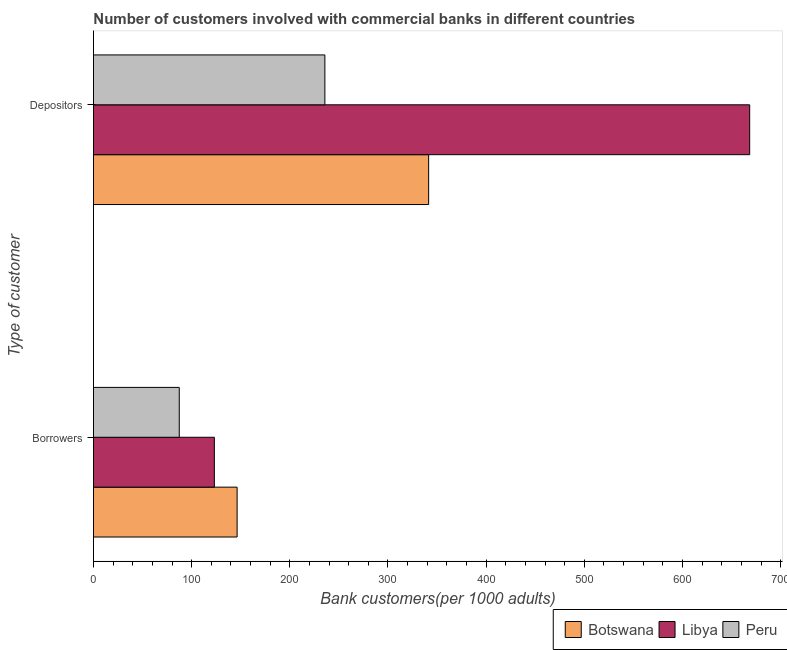How many groups of bars are there?
Your response must be concise. 2. Are the number of bars per tick equal to the number of legend labels?
Provide a succinct answer. Yes. Are the number of bars on each tick of the Y-axis equal?
Your response must be concise. Yes. How many bars are there on the 2nd tick from the top?
Keep it short and to the point. 3. What is the label of the 2nd group of bars from the top?
Your response must be concise. Borrowers. What is the number of borrowers in Peru?
Your answer should be compact. 87.41. Across all countries, what is the maximum number of borrowers?
Offer a very short reply. 146.32. Across all countries, what is the minimum number of borrowers?
Offer a terse response. 87.41. In which country was the number of borrowers maximum?
Your answer should be very brief. Botswana. In which country was the number of depositors minimum?
Offer a terse response. Peru. What is the total number of borrowers in the graph?
Your response must be concise. 356.88. What is the difference between the number of borrowers in Peru and that in Botswana?
Provide a succinct answer. -58.91. What is the difference between the number of depositors in Peru and the number of borrowers in Libya?
Keep it short and to the point. 112.56. What is the average number of depositors per country?
Offer a terse response. 415.17. What is the difference between the number of depositors and number of borrowers in Botswana?
Your answer should be compact. 195.08. What is the ratio of the number of depositors in Peru to that in Libya?
Provide a short and direct response. 0.35. In how many countries, is the number of borrowers greater than the average number of borrowers taken over all countries?
Make the answer very short. 2. What does the 1st bar from the top in Borrowers represents?
Offer a terse response. Peru. What does the 2nd bar from the bottom in Borrowers represents?
Your answer should be compact. Libya. How many bars are there?
Offer a very short reply. 6. Are all the bars in the graph horizontal?
Provide a succinct answer. Yes. How many countries are there in the graph?
Keep it short and to the point. 3. What is the difference between two consecutive major ticks on the X-axis?
Offer a very short reply. 100. Are the values on the major ticks of X-axis written in scientific E-notation?
Provide a short and direct response. No. Does the graph contain any zero values?
Ensure brevity in your answer.  No. Where does the legend appear in the graph?
Offer a very short reply. Bottom right. How many legend labels are there?
Your response must be concise. 3. What is the title of the graph?
Your answer should be compact. Number of customers involved with commercial banks in different countries. What is the label or title of the X-axis?
Provide a short and direct response. Bank customers(per 1000 adults). What is the label or title of the Y-axis?
Offer a terse response. Type of customer. What is the Bank customers(per 1000 adults) in Botswana in Borrowers?
Ensure brevity in your answer.  146.32. What is the Bank customers(per 1000 adults) in Libya in Borrowers?
Your answer should be compact. 123.15. What is the Bank customers(per 1000 adults) in Peru in Borrowers?
Provide a succinct answer. 87.41. What is the Bank customers(per 1000 adults) of Botswana in Depositors?
Provide a succinct answer. 341.4. What is the Bank customers(per 1000 adults) in Libya in Depositors?
Make the answer very short. 668.4. What is the Bank customers(per 1000 adults) of Peru in Depositors?
Your answer should be compact. 235.71. Across all Type of customer, what is the maximum Bank customers(per 1000 adults) in Botswana?
Give a very brief answer. 341.4. Across all Type of customer, what is the maximum Bank customers(per 1000 adults) of Libya?
Offer a terse response. 668.4. Across all Type of customer, what is the maximum Bank customers(per 1000 adults) of Peru?
Offer a very short reply. 235.71. Across all Type of customer, what is the minimum Bank customers(per 1000 adults) of Botswana?
Offer a terse response. 146.32. Across all Type of customer, what is the minimum Bank customers(per 1000 adults) of Libya?
Offer a terse response. 123.15. Across all Type of customer, what is the minimum Bank customers(per 1000 adults) of Peru?
Ensure brevity in your answer.  87.41. What is the total Bank customers(per 1000 adults) of Botswana in the graph?
Ensure brevity in your answer.  487.72. What is the total Bank customers(per 1000 adults) in Libya in the graph?
Provide a short and direct response. 791.55. What is the total Bank customers(per 1000 adults) in Peru in the graph?
Provide a short and direct response. 323.12. What is the difference between the Bank customers(per 1000 adults) in Botswana in Borrowers and that in Depositors?
Your response must be concise. -195.08. What is the difference between the Bank customers(per 1000 adults) of Libya in Borrowers and that in Depositors?
Give a very brief answer. -545.24. What is the difference between the Bank customers(per 1000 adults) of Peru in Borrowers and that in Depositors?
Give a very brief answer. -148.3. What is the difference between the Bank customers(per 1000 adults) in Botswana in Borrowers and the Bank customers(per 1000 adults) in Libya in Depositors?
Provide a short and direct response. -522.08. What is the difference between the Bank customers(per 1000 adults) in Botswana in Borrowers and the Bank customers(per 1000 adults) in Peru in Depositors?
Give a very brief answer. -89.39. What is the difference between the Bank customers(per 1000 adults) in Libya in Borrowers and the Bank customers(per 1000 adults) in Peru in Depositors?
Give a very brief answer. -112.56. What is the average Bank customers(per 1000 adults) of Botswana per Type of customer?
Ensure brevity in your answer.  243.86. What is the average Bank customers(per 1000 adults) in Libya per Type of customer?
Your answer should be compact. 395.77. What is the average Bank customers(per 1000 adults) in Peru per Type of customer?
Your answer should be compact. 161.56. What is the difference between the Bank customers(per 1000 adults) in Botswana and Bank customers(per 1000 adults) in Libya in Borrowers?
Make the answer very short. 23.17. What is the difference between the Bank customers(per 1000 adults) of Botswana and Bank customers(per 1000 adults) of Peru in Borrowers?
Keep it short and to the point. 58.91. What is the difference between the Bank customers(per 1000 adults) in Libya and Bank customers(per 1000 adults) in Peru in Borrowers?
Your response must be concise. 35.74. What is the difference between the Bank customers(per 1000 adults) in Botswana and Bank customers(per 1000 adults) in Libya in Depositors?
Ensure brevity in your answer.  -326.99. What is the difference between the Bank customers(per 1000 adults) of Botswana and Bank customers(per 1000 adults) of Peru in Depositors?
Provide a short and direct response. 105.69. What is the difference between the Bank customers(per 1000 adults) of Libya and Bank customers(per 1000 adults) of Peru in Depositors?
Give a very brief answer. 432.68. What is the ratio of the Bank customers(per 1000 adults) in Botswana in Borrowers to that in Depositors?
Provide a succinct answer. 0.43. What is the ratio of the Bank customers(per 1000 adults) of Libya in Borrowers to that in Depositors?
Your response must be concise. 0.18. What is the ratio of the Bank customers(per 1000 adults) of Peru in Borrowers to that in Depositors?
Offer a very short reply. 0.37. What is the difference between the highest and the second highest Bank customers(per 1000 adults) of Botswana?
Your answer should be compact. 195.08. What is the difference between the highest and the second highest Bank customers(per 1000 adults) in Libya?
Your answer should be compact. 545.24. What is the difference between the highest and the second highest Bank customers(per 1000 adults) in Peru?
Provide a short and direct response. 148.3. What is the difference between the highest and the lowest Bank customers(per 1000 adults) of Botswana?
Provide a succinct answer. 195.08. What is the difference between the highest and the lowest Bank customers(per 1000 adults) in Libya?
Your response must be concise. 545.24. What is the difference between the highest and the lowest Bank customers(per 1000 adults) in Peru?
Provide a succinct answer. 148.3. 